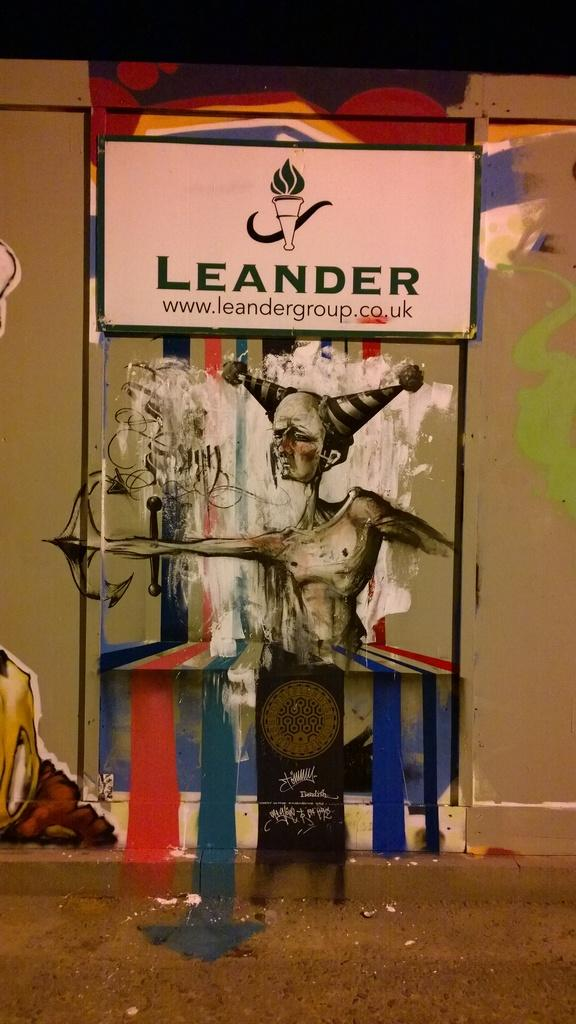What is the main object in the image? There is a name board in the image. Where is the name board located? The name board is attached to a wall. What else can be seen on the wall in the image? There is a wall painting in the image. What can be said about the appearance of the wall painting? The wall painting has different colors. How many fowl are present in the image? There are no fowl present in the image. Is there a birthday celebration happening in the image? There is no indication of a birthday celebration in the image. 